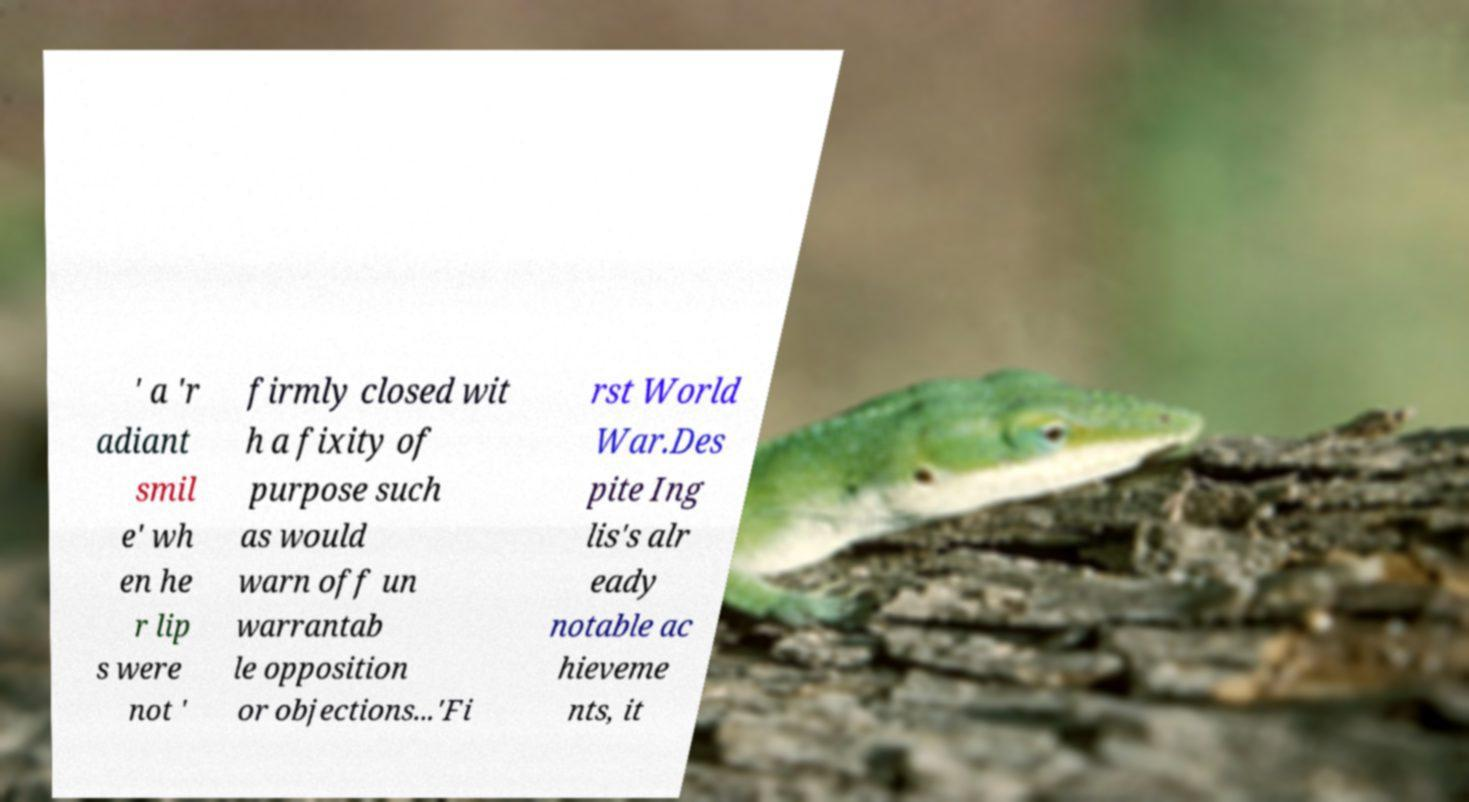There's text embedded in this image that I need extracted. Can you transcribe it verbatim? ' a 'r adiant smil e' wh en he r lip s were not ' firmly closed wit h a fixity of purpose such as would warn off un warrantab le opposition or objections...'Fi rst World War.Des pite Ing lis's alr eady notable ac hieveme nts, it 